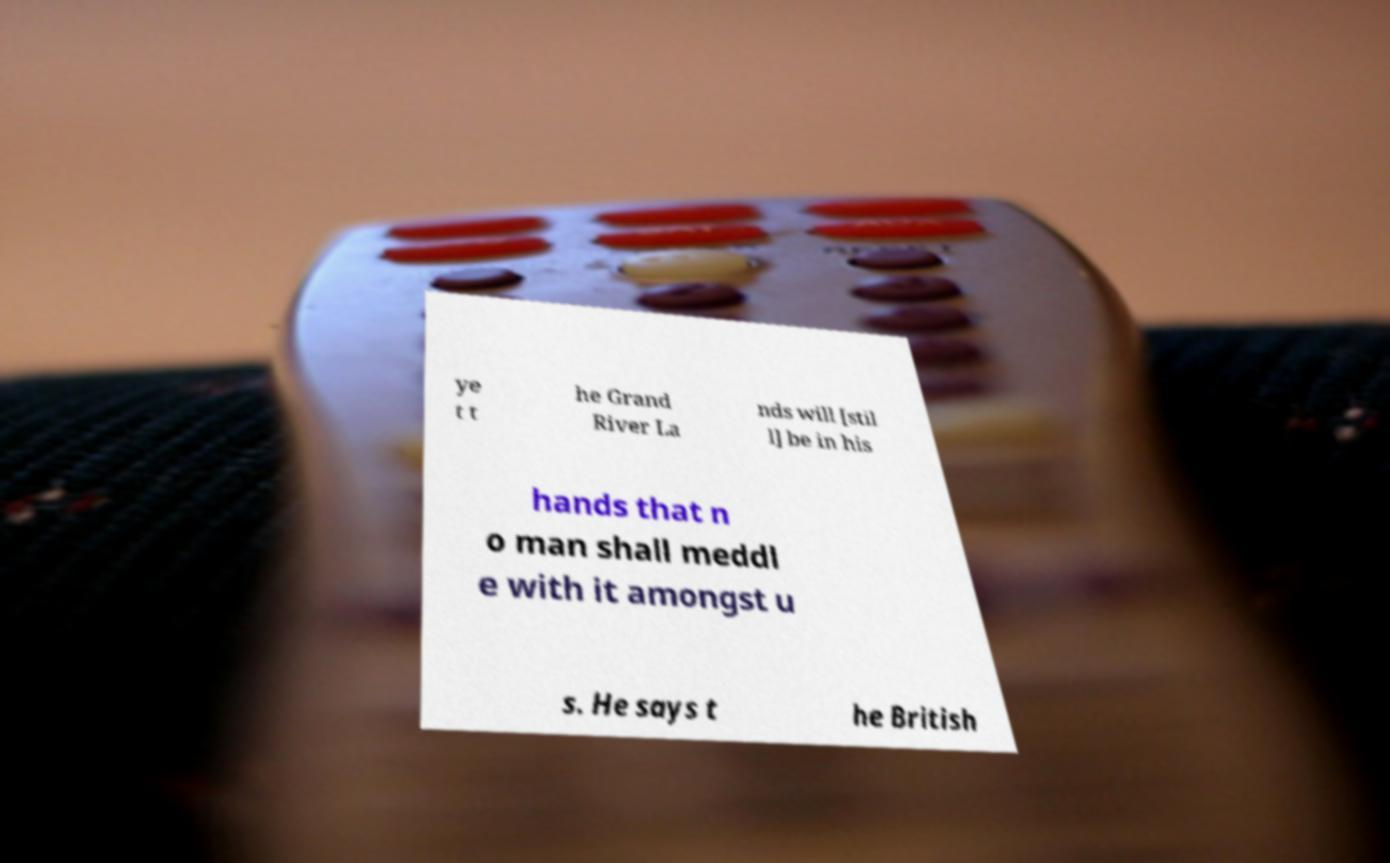Can you read and provide the text displayed in the image?This photo seems to have some interesting text. Can you extract and type it out for me? ye t t he Grand River La nds will [stil l] be in his hands that n o man shall meddl e with it amongst u s. He says t he British 